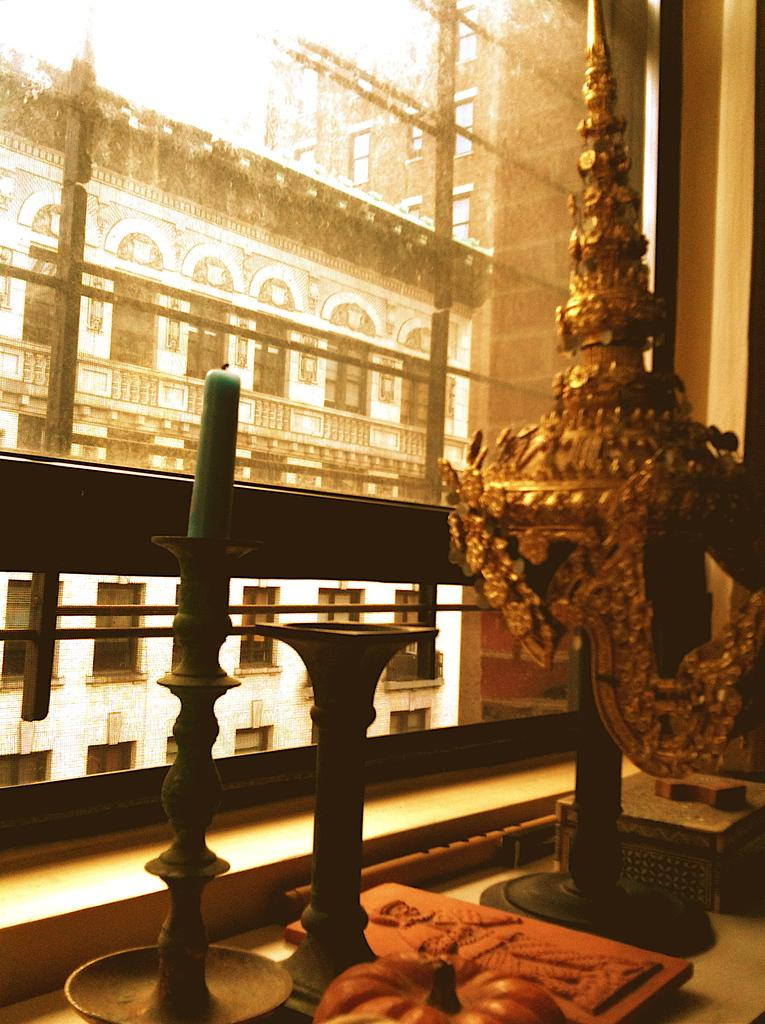What is the main object in the image? There is a candle stand in the image. What type of material is used for the objects in the image? The objects in the image are made up of metal. What can be seen in the foreground of the image? There is a metal railing in the foreground of the image. What is visible in the background of the image? There are buildings in the background of the image. How many pairs of shoes can be seen in the image? There are no shoes present in the image. What type of cave is visible in the background of the image? There is no cave present in the image; it features buildings in the background. 